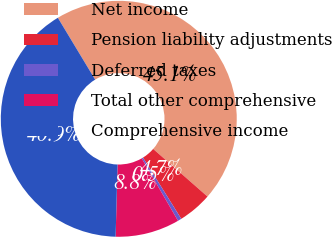Convert chart to OTSL. <chart><loc_0><loc_0><loc_500><loc_500><pie_chart><fcel>Net income<fcel>Pension liability adjustments<fcel>Deferred taxes<fcel>Total other comprehensive<fcel>Comprehensive income<nl><fcel>45.09%<fcel>4.66%<fcel>0.51%<fcel>8.8%<fcel>40.94%<nl></chart> 